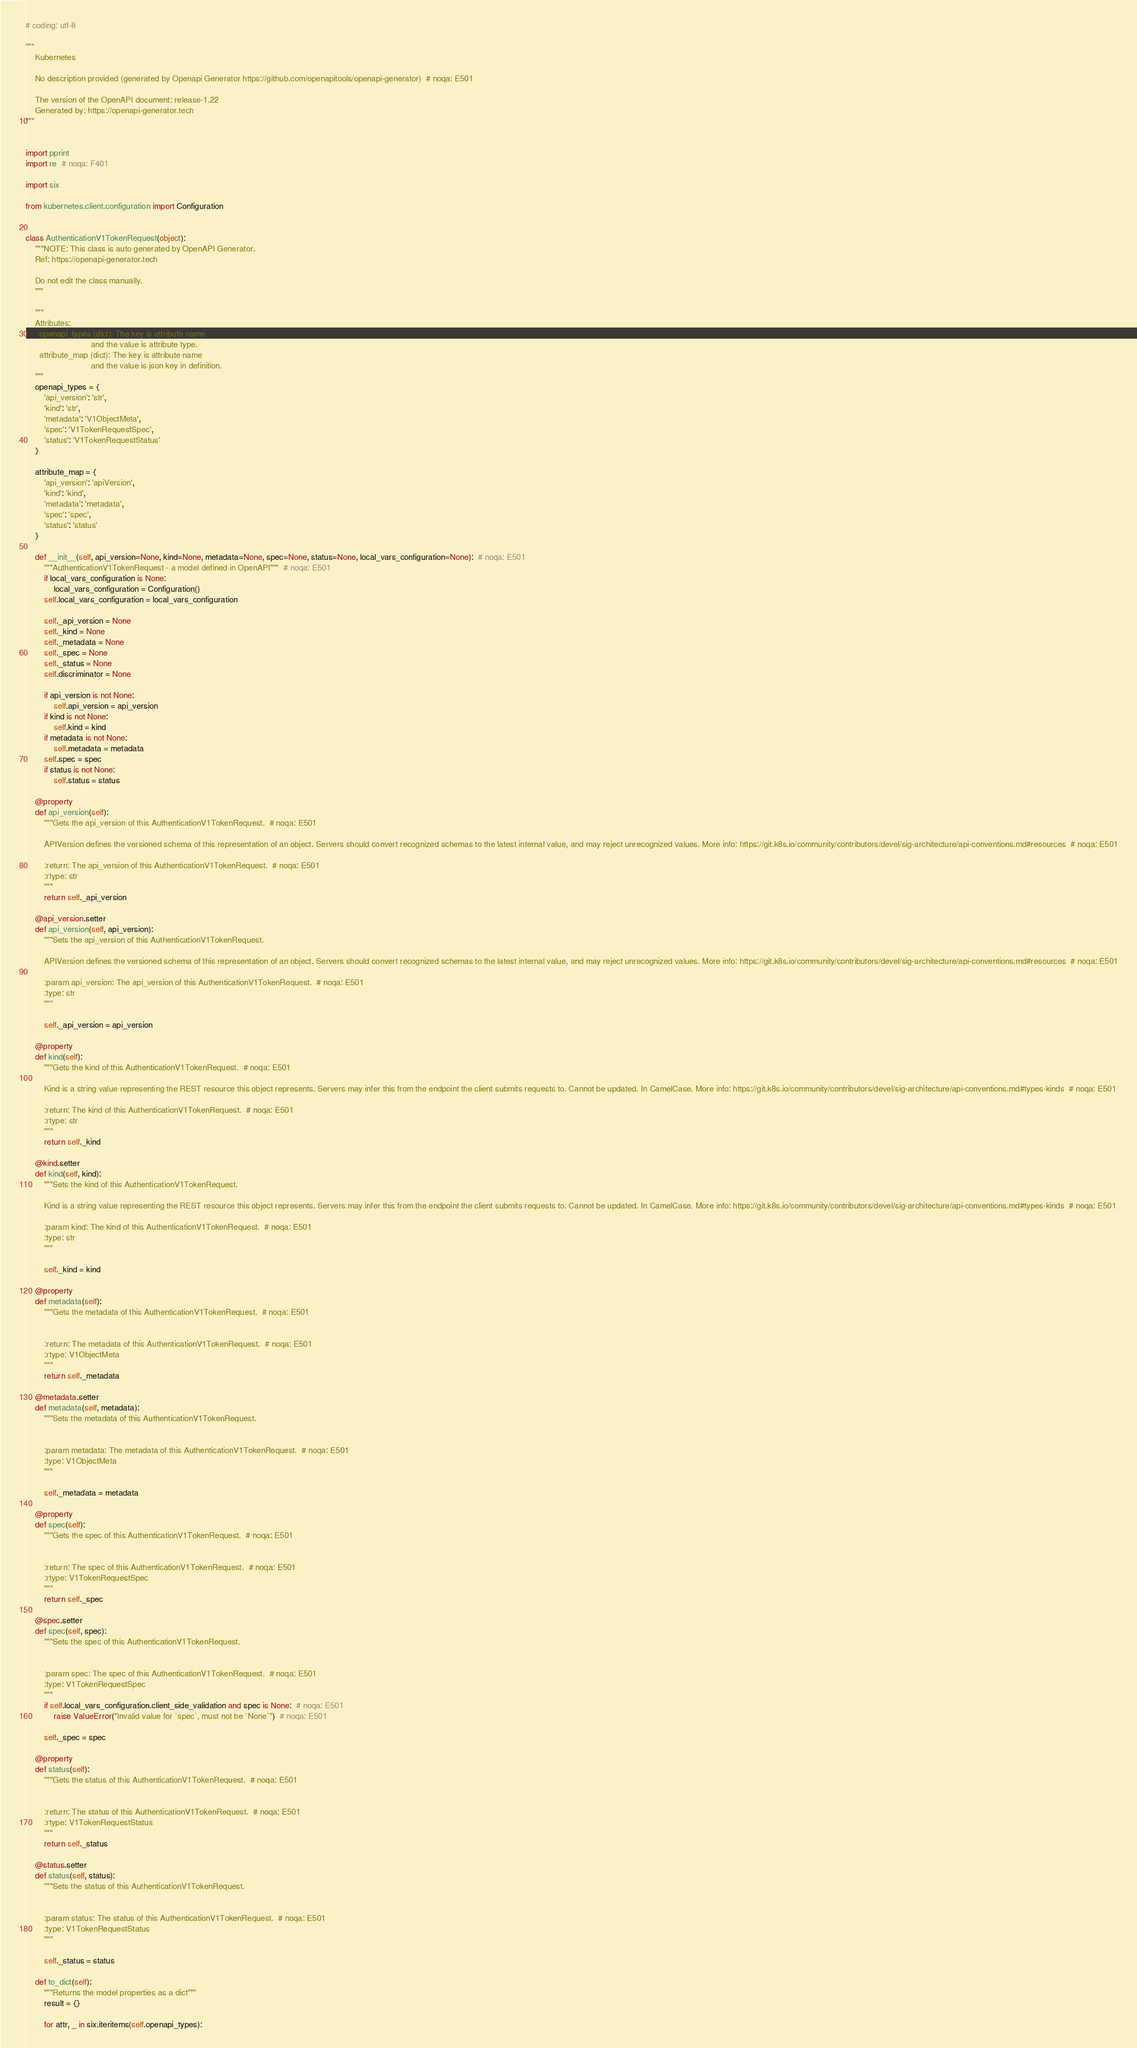<code> <loc_0><loc_0><loc_500><loc_500><_Python_># coding: utf-8

"""
    Kubernetes

    No description provided (generated by Openapi Generator https://github.com/openapitools/openapi-generator)  # noqa: E501

    The version of the OpenAPI document: release-1.22
    Generated by: https://openapi-generator.tech
"""


import pprint
import re  # noqa: F401

import six

from kubernetes.client.configuration import Configuration


class AuthenticationV1TokenRequest(object):
    """NOTE: This class is auto generated by OpenAPI Generator.
    Ref: https://openapi-generator.tech

    Do not edit the class manually.
    """

    """
    Attributes:
      openapi_types (dict): The key is attribute name
                            and the value is attribute type.
      attribute_map (dict): The key is attribute name
                            and the value is json key in definition.
    """
    openapi_types = {
        'api_version': 'str',
        'kind': 'str',
        'metadata': 'V1ObjectMeta',
        'spec': 'V1TokenRequestSpec',
        'status': 'V1TokenRequestStatus'
    }

    attribute_map = {
        'api_version': 'apiVersion',
        'kind': 'kind',
        'metadata': 'metadata',
        'spec': 'spec',
        'status': 'status'
    }

    def __init__(self, api_version=None, kind=None, metadata=None, spec=None, status=None, local_vars_configuration=None):  # noqa: E501
        """AuthenticationV1TokenRequest - a model defined in OpenAPI"""  # noqa: E501
        if local_vars_configuration is None:
            local_vars_configuration = Configuration()
        self.local_vars_configuration = local_vars_configuration

        self._api_version = None
        self._kind = None
        self._metadata = None
        self._spec = None
        self._status = None
        self.discriminator = None

        if api_version is not None:
            self.api_version = api_version
        if kind is not None:
            self.kind = kind
        if metadata is not None:
            self.metadata = metadata
        self.spec = spec
        if status is not None:
            self.status = status

    @property
    def api_version(self):
        """Gets the api_version of this AuthenticationV1TokenRequest.  # noqa: E501

        APIVersion defines the versioned schema of this representation of an object. Servers should convert recognized schemas to the latest internal value, and may reject unrecognized values. More info: https://git.k8s.io/community/contributors/devel/sig-architecture/api-conventions.md#resources  # noqa: E501

        :return: The api_version of this AuthenticationV1TokenRequest.  # noqa: E501
        :rtype: str
        """
        return self._api_version

    @api_version.setter
    def api_version(self, api_version):
        """Sets the api_version of this AuthenticationV1TokenRequest.

        APIVersion defines the versioned schema of this representation of an object. Servers should convert recognized schemas to the latest internal value, and may reject unrecognized values. More info: https://git.k8s.io/community/contributors/devel/sig-architecture/api-conventions.md#resources  # noqa: E501

        :param api_version: The api_version of this AuthenticationV1TokenRequest.  # noqa: E501
        :type: str
        """

        self._api_version = api_version

    @property
    def kind(self):
        """Gets the kind of this AuthenticationV1TokenRequest.  # noqa: E501

        Kind is a string value representing the REST resource this object represents. Servers may infer this from the endpoint the client submits requests to. Cannot be updated. In CamelCase. More info: https://git.k8s.io/community/contributors/devel/sig-architecture/api-conventions.md#types-kinds  # noqa: E501

        :return: The kind of this AuthenticationV1TokenRequest.  # noqa: E501
        :rtype: str
        """
        return self._kind

    @kind.setter
    def kind(self, kind):
        """Sets the kind of this AuthenticationV1TokenRequest.

        Kind is a string value representing the REST resource this object represents. Servers may infer this from the endpoint the client submits requests to. Cannot be updated. In CamelCase. More info: https://git.k8s.io/community/contributors/devel/sig-architecture/api-conventions.md#types-kinds  # noqa: E501

        :param kind: The kind of this AuthenticationV1TokenRequest.  # noqa: E501
        :type: str
        """

        self._kind = kind

    @property
    def metadata(self):
        """Gets the metadata of this AuthenticationV1TokenRequest.  # noqa: E501


        :return: The metadata of this AuthenticationV1TokenRequest.  # noqa: E501
        :rtype: V1ObjectMeta
        """
        return self._metadata

    @metadata.setter
    def metadata(self, metadata):
        """Sets the metadata of this AuthenticationV1TokenRequest.


        :param metadata: The metadata of this AuthenticationV1TokenRequest.  # noqa: E501
        :type: V1ObjectMeta
        """

        self._metadata = metadata

    @property
    def spec(self):
        """Gets the spec of this AuthenticationV1TokenRequest.  # noqa: E501


        :return: The spec of this AuthenticationV1TokenRequest.  # noqa: E501
        :rtype: V1TokenRequestSpec
        """
        return self._spec

    @spec.setter
    def spec(self, spec):
        """Sets the spec of this AuthenticationV1TokenRequest.


        :param spec: The spec of this AuthenticationV1TokenRequest.  # noqa: E501
        :type: V1TokenRequestSpec
        """
        if self.local_vars_configuration.client_side_validation and spec is None:  # noqa: E501
            raise ValueError("Invalid value for `spec`, must not be `None`")  # noqa: E501

        self._spec = spec

    @property
    def status(self):
        """Gets the status of this AuthenticationV1TokenRequest.  # noqa: E501


        :return: The status of this AuthenticationV1TokenRequest.  # noqa: E501
        :rtype: V1TokenRequestStatus
        """
        return self._status

    @status.setter
    def status(self, status):
        """Sets the status of this AuthenticationV1TokenRequest.


        :param status: The status of this AuthenticationV1TokenRequest.  # noqa: E501
        :type: V1TokenRequestStatus
        """

        self._status = status

    def to_dict(self):
        """Returns the model properties as a dict"""
        result = {}

        for attr, _ in six.iteritems(self.openapi_types):</code> 